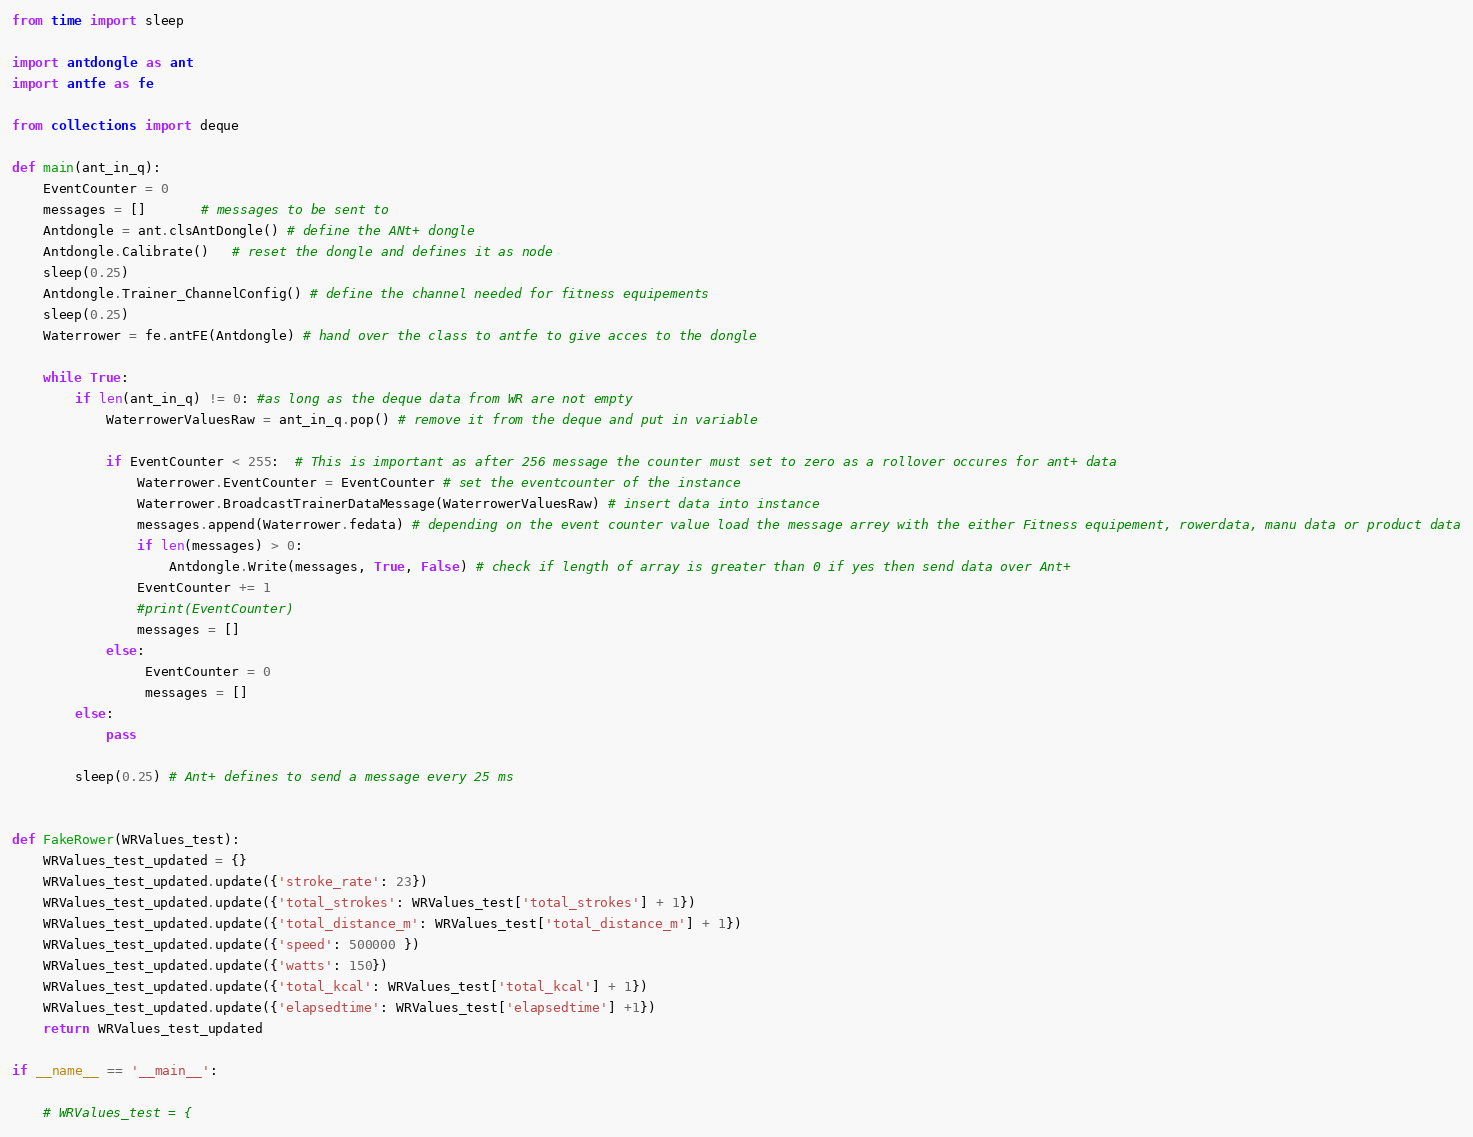Convert code to text. <code><loc_0><loc_0><loc_500><loc_500><_Python_>
from time import sleep

import antdongle as ant
import antfe as fe

from collections import deque

def main(ant_in_q):
    EventCounter = 0
    messages = []       # messages to be sent to
    Antdongle = ant.clsAntDongle() # define the ANt+ dongle
    Antdongle.Calibrate()   # reset the dongle and defines it as node
    sleep(0.25)
    Antdongle.Trainer_ChannelConfig() # define the channel needed for fitness equipements
    sleep(0.25)
    Waterrower = fe.antFE(Antdongle) # hand over the class to antfe to give acces to the dongle

    while True:
        if len(ant_in_q) != 0: #as long as the deque data from WR are not empty
            WaterrowerValuesRaw = ant_in_q.pop() # remove it from the deque and put in variable

            if EventCounter < 255:  # This is important as after 256 message the counter must set to zero as a rollover occures for ant+ data
                Waterrower.EventCounter = EventCounter # set the eventcounter of the instance
                Waterrower.BroadcastTrainerDataMessage(WaterrowerValuesRaw) # insert data into instance
                messages.append(Waterrower.fedata) # depending on the event counter value load the message arrey with the either Fitness equipement, rowerdata, manu data or product data
                if len(messages) > 0:
                    Antdongle.Write(messages, True, False) # check if length of array is greater than 0 if yes then send data over Ant+
                EventCounter += 1
                #print(EventCounter)
                messages = []
            else:
                 EventCounter = 0
                 messages = []
        else:
            pass

        sleep(0.25) # Ant+ defines to send a message every 25 ms


def FakeRower(WRValues_test):
    WRValues_test_updated = {}
    WRValues_test_updated.update({'stroke_rate': 23})
    WRValues_test_updated.update({'total_strokes': WRValues_test['total_strokes'] + 1})
    WRValues_test_updated.update({'total_distance_m': WRValues_test['total_distance_m'] + 1})
    WRValues_test_updated.update({'speed': 500000 })
    WRValues_test_updated.update({'watts': 150})
    WRValues_test_updated.update({'total_kcal': WRValues_test['total_kcal'] + 1})
    WRValues_test_updated.update({'elapsedtime': WRValues_test['elapsedtime'] +1})
    return WRValues_test_updated

if __name__ == '__main__':

    # WRValues_test = {</code> 